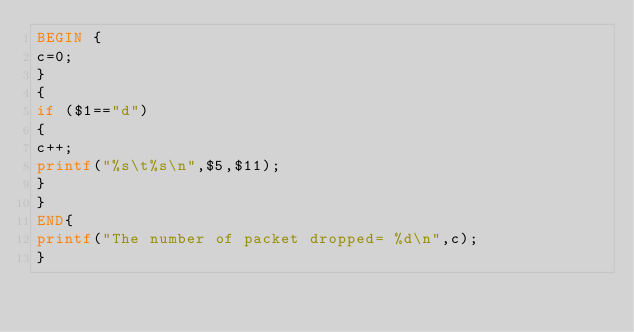Convert code to text. <code><loc_0><loc_0><loc_500><loc_500><_Awk_>BEGIN {
c=0;
}
{
if ($1=="d")
{
c++;
printf("%s\t%s\n",$5,$11);
}
}
END{
printf("The number of packet dropped= %d\n",c);
}</code> 